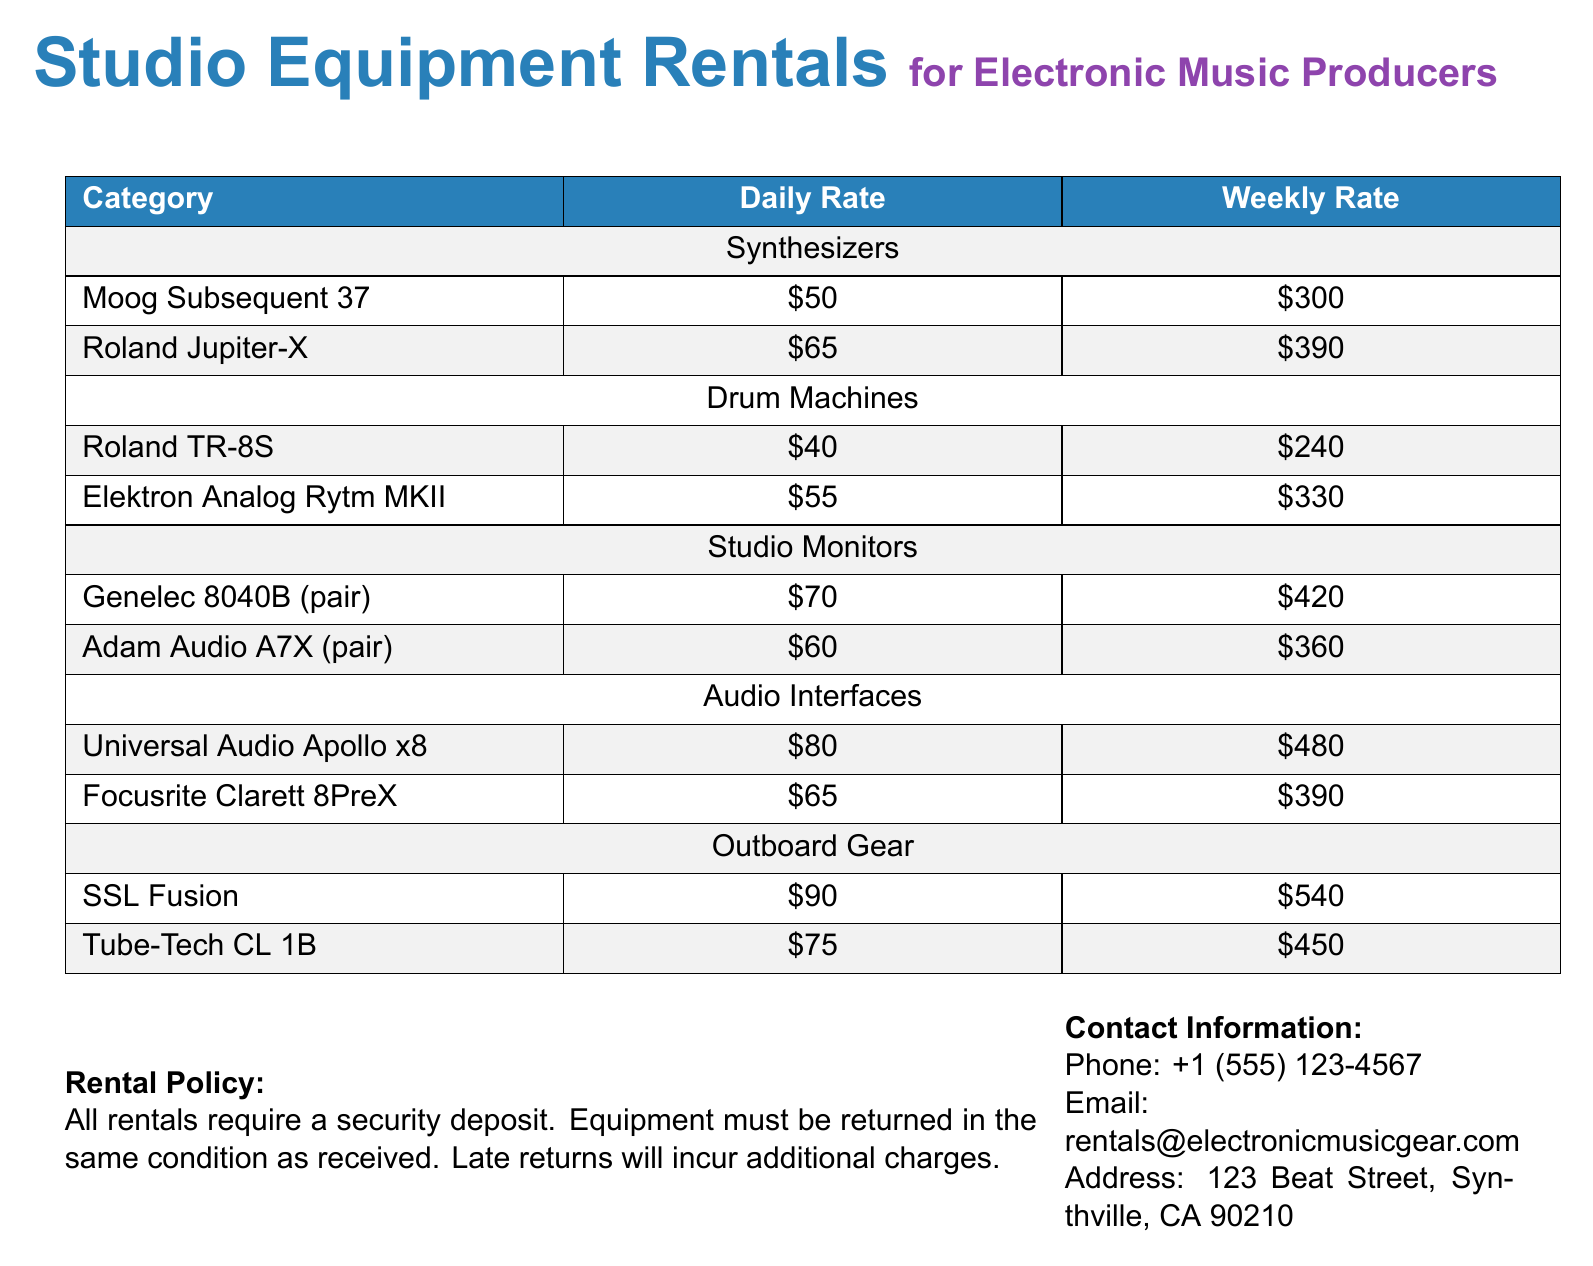what is the rental rate for the Moog Subsequent 37? The rental rate for the Moog Subsequent 37 is listed as $50 for daily and $300 for weekly.
Answer: $50 how much does it cost to rent the Genelec 8040B pair for a week? The weekly rate for renting the Genelec 8040B pair is provided as $420.
Answer: $420 which audio interface has the highest rental rate? The document lists the Universal Audio Apollo x8 as the audio interface with the highest rental rate at $80 daily and $480 weekly.
Answer: Universal Audio Apollo x8 what is the total weekly rental rate for all synthesizers? The weekly rental rates for synthesizers are $300 (Moog Subsequent 37) + $390 (Roland Jupiter-X) = $690 total.
Answer: $690 which category has the lowest daily rental rate? The category with the lowest daily rental rate is Drum Machines, with the Roland TR-8S at $40 daily.
Answer: Drum Machines how much is the security deposit required for rentals? The document does not specify the amount of the security deposit required for rentals.
Answer: Not specified what are the contact methods provided for equipment rental inquiries? Contact methods include phone, email, and physical address listed for inquiries.
Answer: Phone, Email, Address what is the return policy regarding the condition of the equipment? The rental policy states that the equipment must be returned in the same condition as received.
Answer: Same condition how many categories of equipment are listed in the document? The document lists five categories of equipment available for rent.
Answer: Five categories 